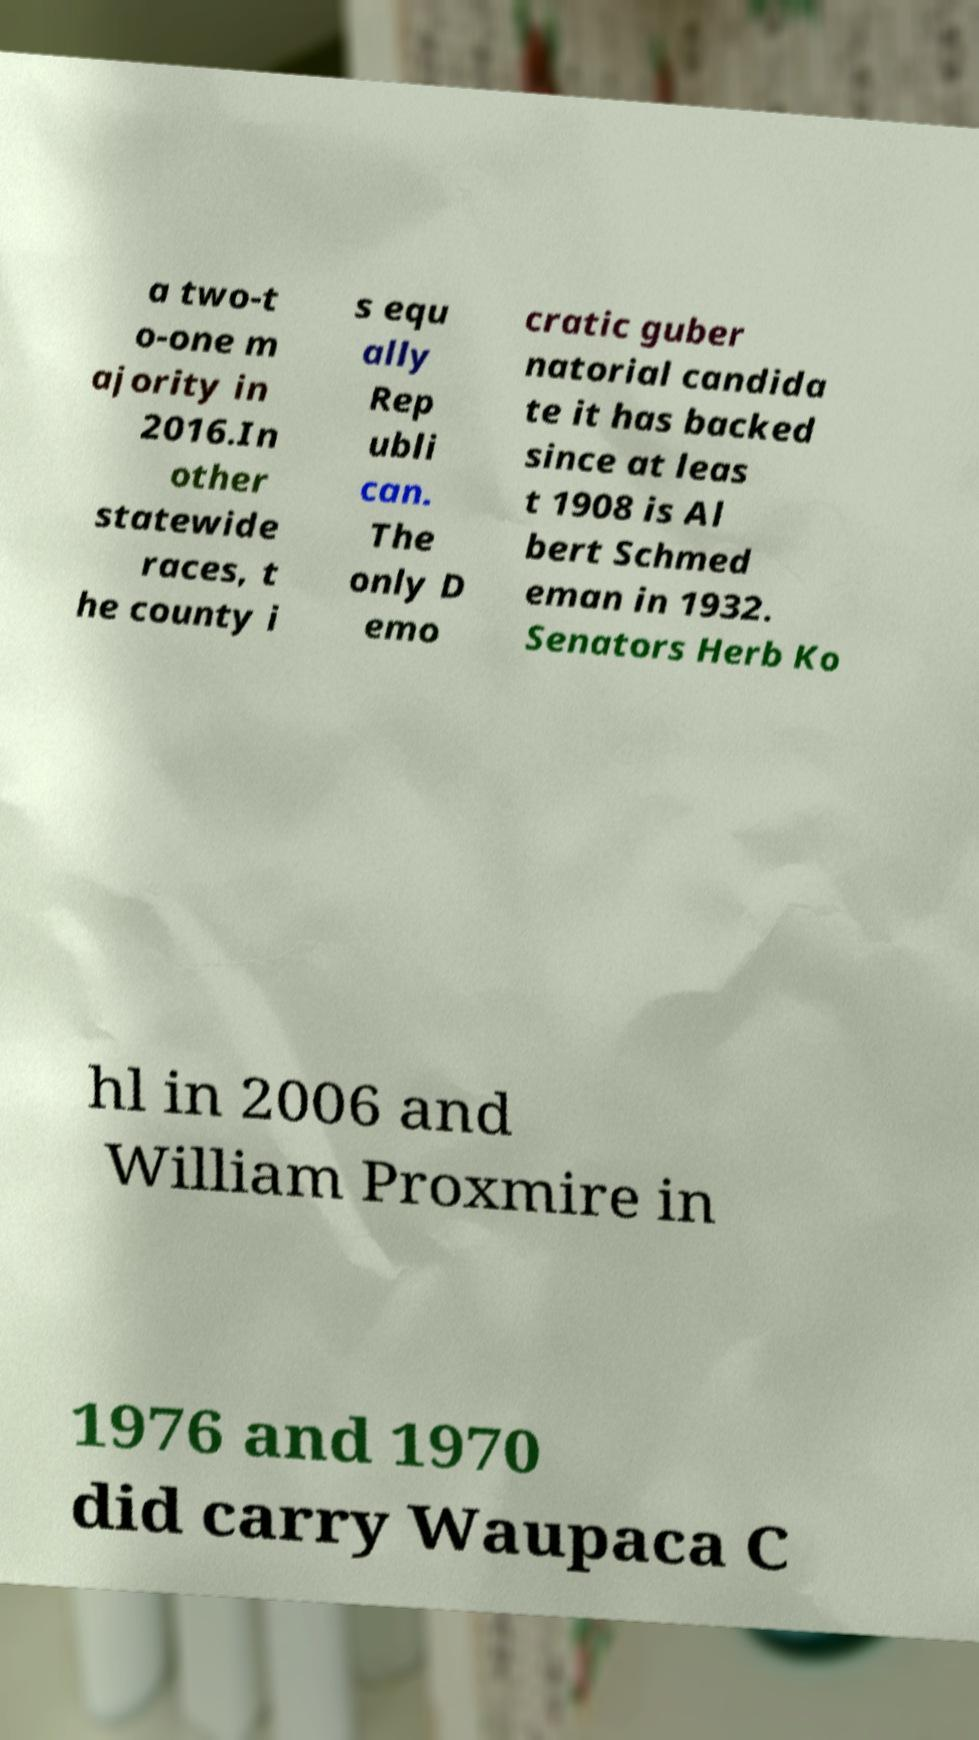Can you read and provide the text displayed in the image?This photo seems to have some interesting text. Can you extract and type it out for me? a two-t o-one m ajority in 2016.In other statewide races, t he county i s equ ally Rep ubli can. The only D emo cratic guber natorial candida te it has backed since at leas t 1908 is Al bert Schmed eman in 1932. Senators Herb Ko hl in 2006 and William Proxmire in 1976 and 1970 did carry Waupaca C 